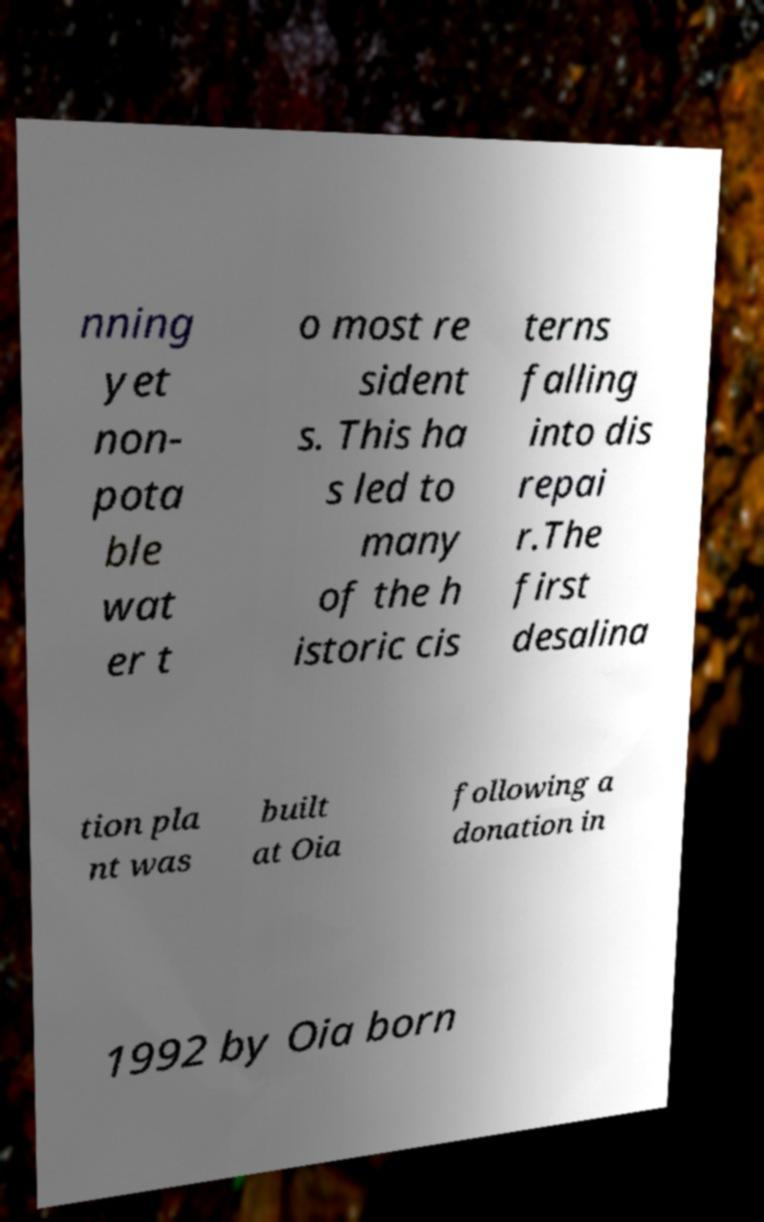There's text embedded in this image that I need extracted. Can you transcribe it verbatim? nning yet non- pota ble wat er t o most re sident s. This ha s led to many of the h istoric cis terns falling into dis repai r.The first desalina tion pla nt was built at Oia following a donation in 1992 by Oia born 